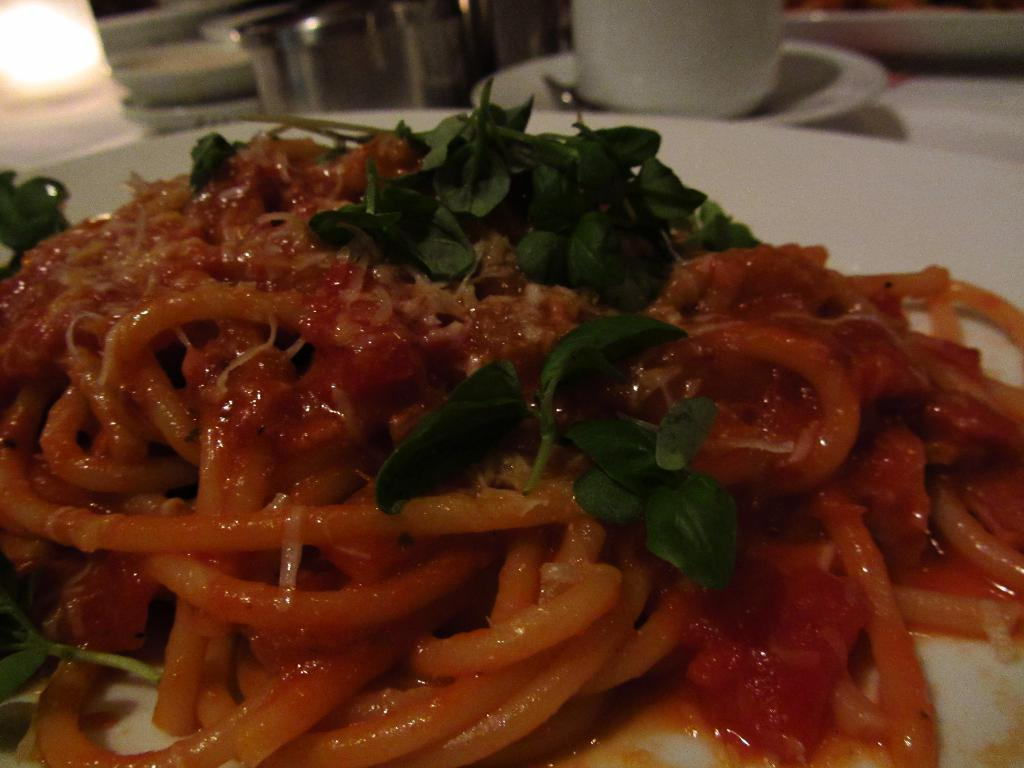What type of food is visible in the image? The food in the image has green and red colors. Can you describe the colors of the food? The food has green and red colors. What is located in the background of the image? There is a cup in the background of the image. What is the color of the cup? The cup is white in color. How does the food contribute to harmony in the image? The image does not depict harmony or any related concept; it simply shows food with green and red colors and a white cup in the background. 